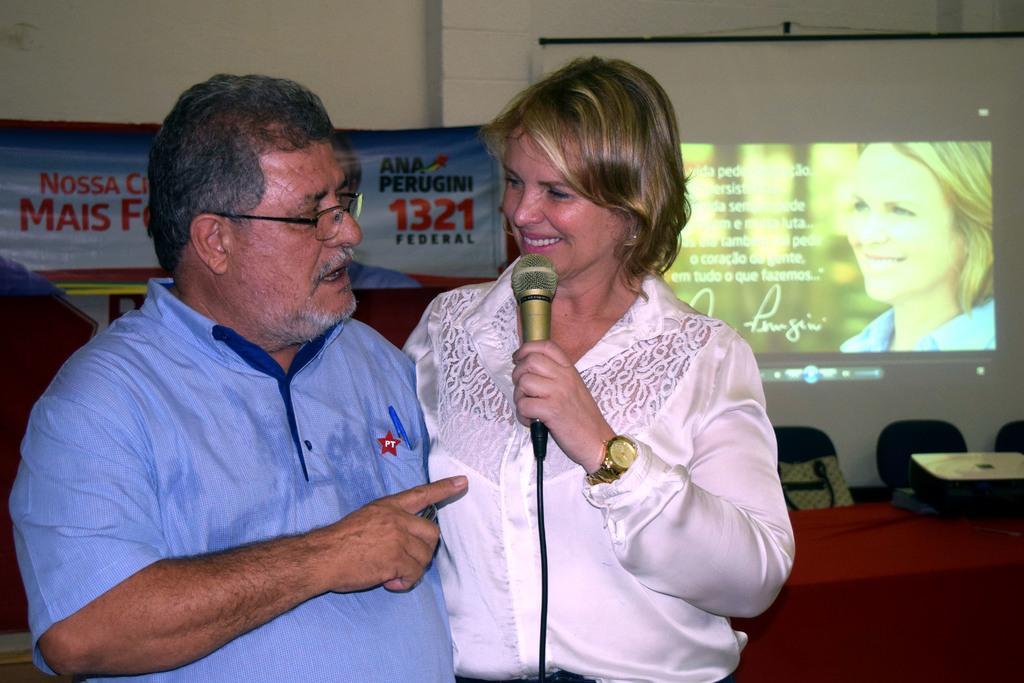Please provide a concise description of this image. This picture shows a man and a woman standing and we see women speaking with the help of a microphone in her hand and we see a projector screen and a banner on their back and we see couple of chairs 